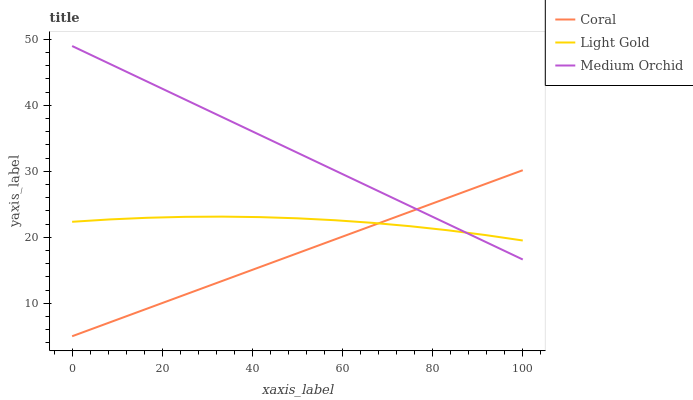Does Light Gold have the minimum area under the curve?
Answer yes or no. No. Does Light Gold have the maximum area under the curve?
Answer yes or no. No. Is Light Gold the smoothest?
Answer yes or no. No. Is Medium Orchid the roughest?
Answer yes or no. No. Does Medium Orchid have the lowest value?
Answer yes or no. No. Does Light Gold have the highest value?
Answer yes or no. No. 